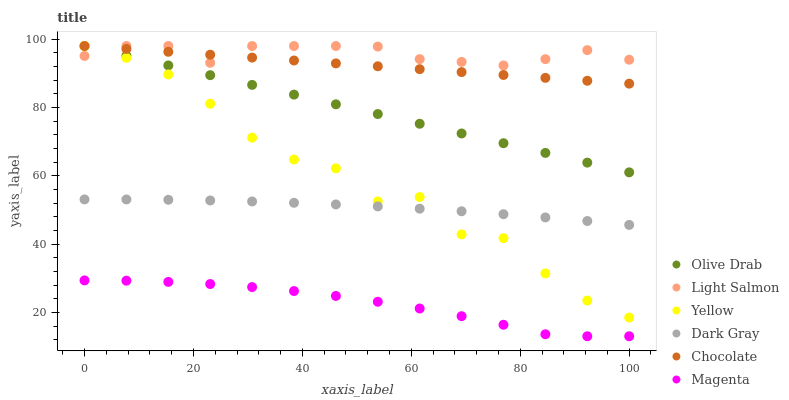Does Magenta have the minimum area under the curve?
Answer yes or no. Yes. Does Light Salmon have the maximum area under the curve?
Answer yes or no. Yes. Does Yellow have the minimum area under the curve?
Answer yes or no. No. Does Yellow have the maximum area under the curve?
Answer yes or no. No. Is Chocolate the smoothest?
Answer yes or no. Yes. Is Yellow the roughest?
Answer yes or no. Yes. Is Yellow the smoothest?
Answer yes or no. No. Is Chocolate the roughest?
Answer yes or no. No. Does Magenta have the lowest value?
Answer yes or no. Yes. Does Yellow have the lowest value?
Answer yes or no. No. Does Olive Drab have the highest value?
Answer yes or no. Yes. Does Dark Gray have the highest value?
Answer yes or no. No. Is Magenta less than Dark Gray?
Answer yes or no. Yes. Is Dark Gray greater than Magenta?
Answer yes or no. Yes. Does Chocolate intersect Light Salmon?
Answer yes or no. Yes. Is Chocolate less than Light Salmon?
Answer yes or no. No. Is Chocolate greater than Light Salmon?
Answer yes or no. No. Does Magenta intersect Dark Gray?
Answer yes or no. No. 